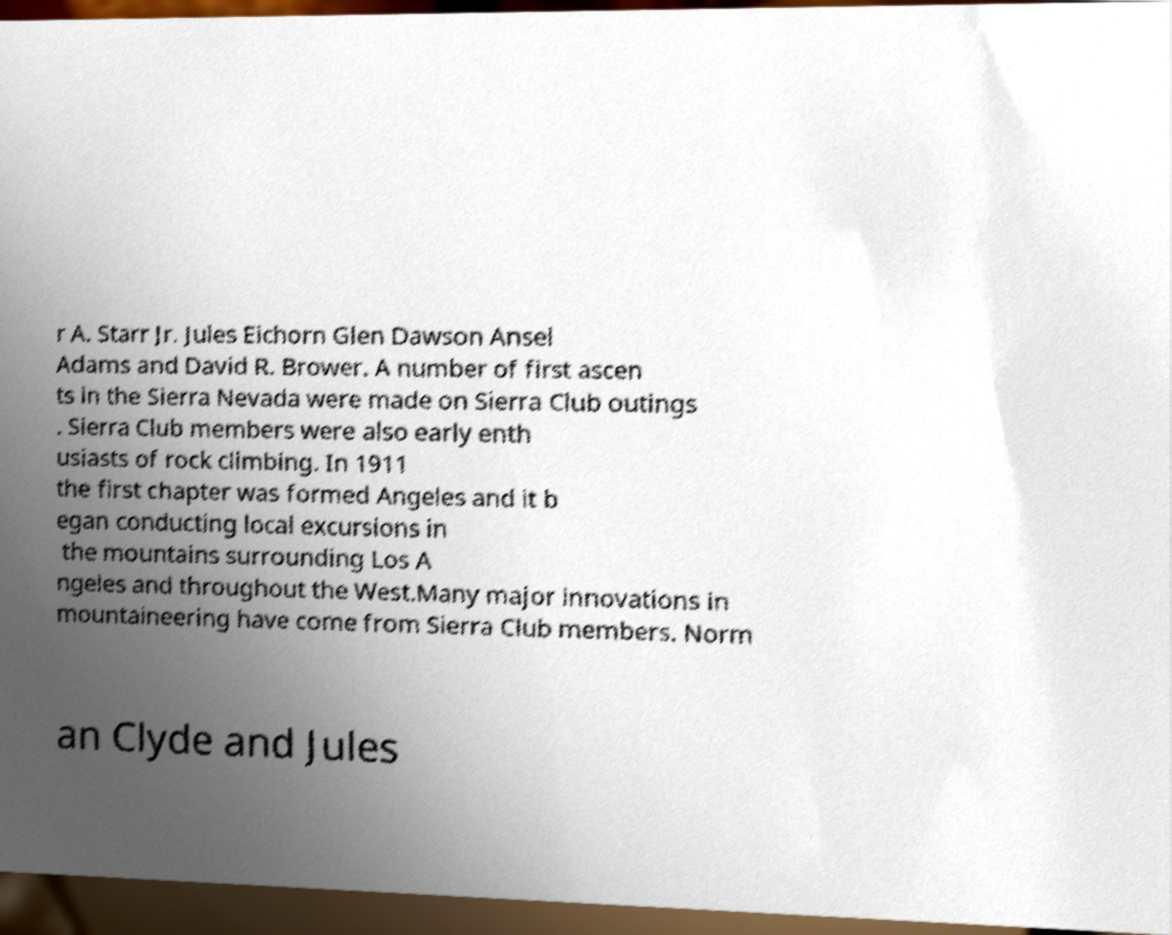Please identify and transcribe the text found in this image. r A. Starr Jr. Jules Eichorn Glen Dawson Ansel Adams and David R. Brower. A number of first ascen ts in the Sierra Nevada were made on Sierra Club outings . Sierra Club members were also early enth usiasts of rock climbing. In 1911 the first chapter was formed Angeles and it b egan conducting local excursions in the mountains surrounding Los A ngeles and throughout the West.Many major innovations in mountaineering have come from Sierra Club members. Norm an Clyde and Jules 